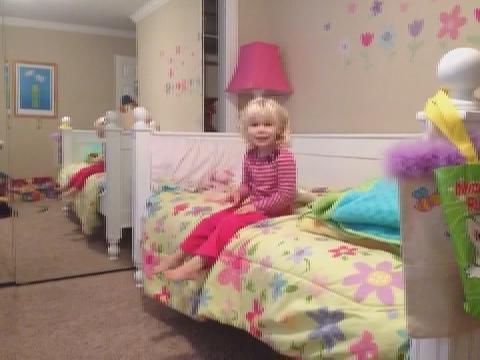What type of finish or item covers the back wall?
Indicate the correct response and explain using: 'Answer: answer
Rationale: rationale.'
Options: Mirror, silver paint, another room, white paint. Answer: mirror.
Rationale: The wall is reflective. 